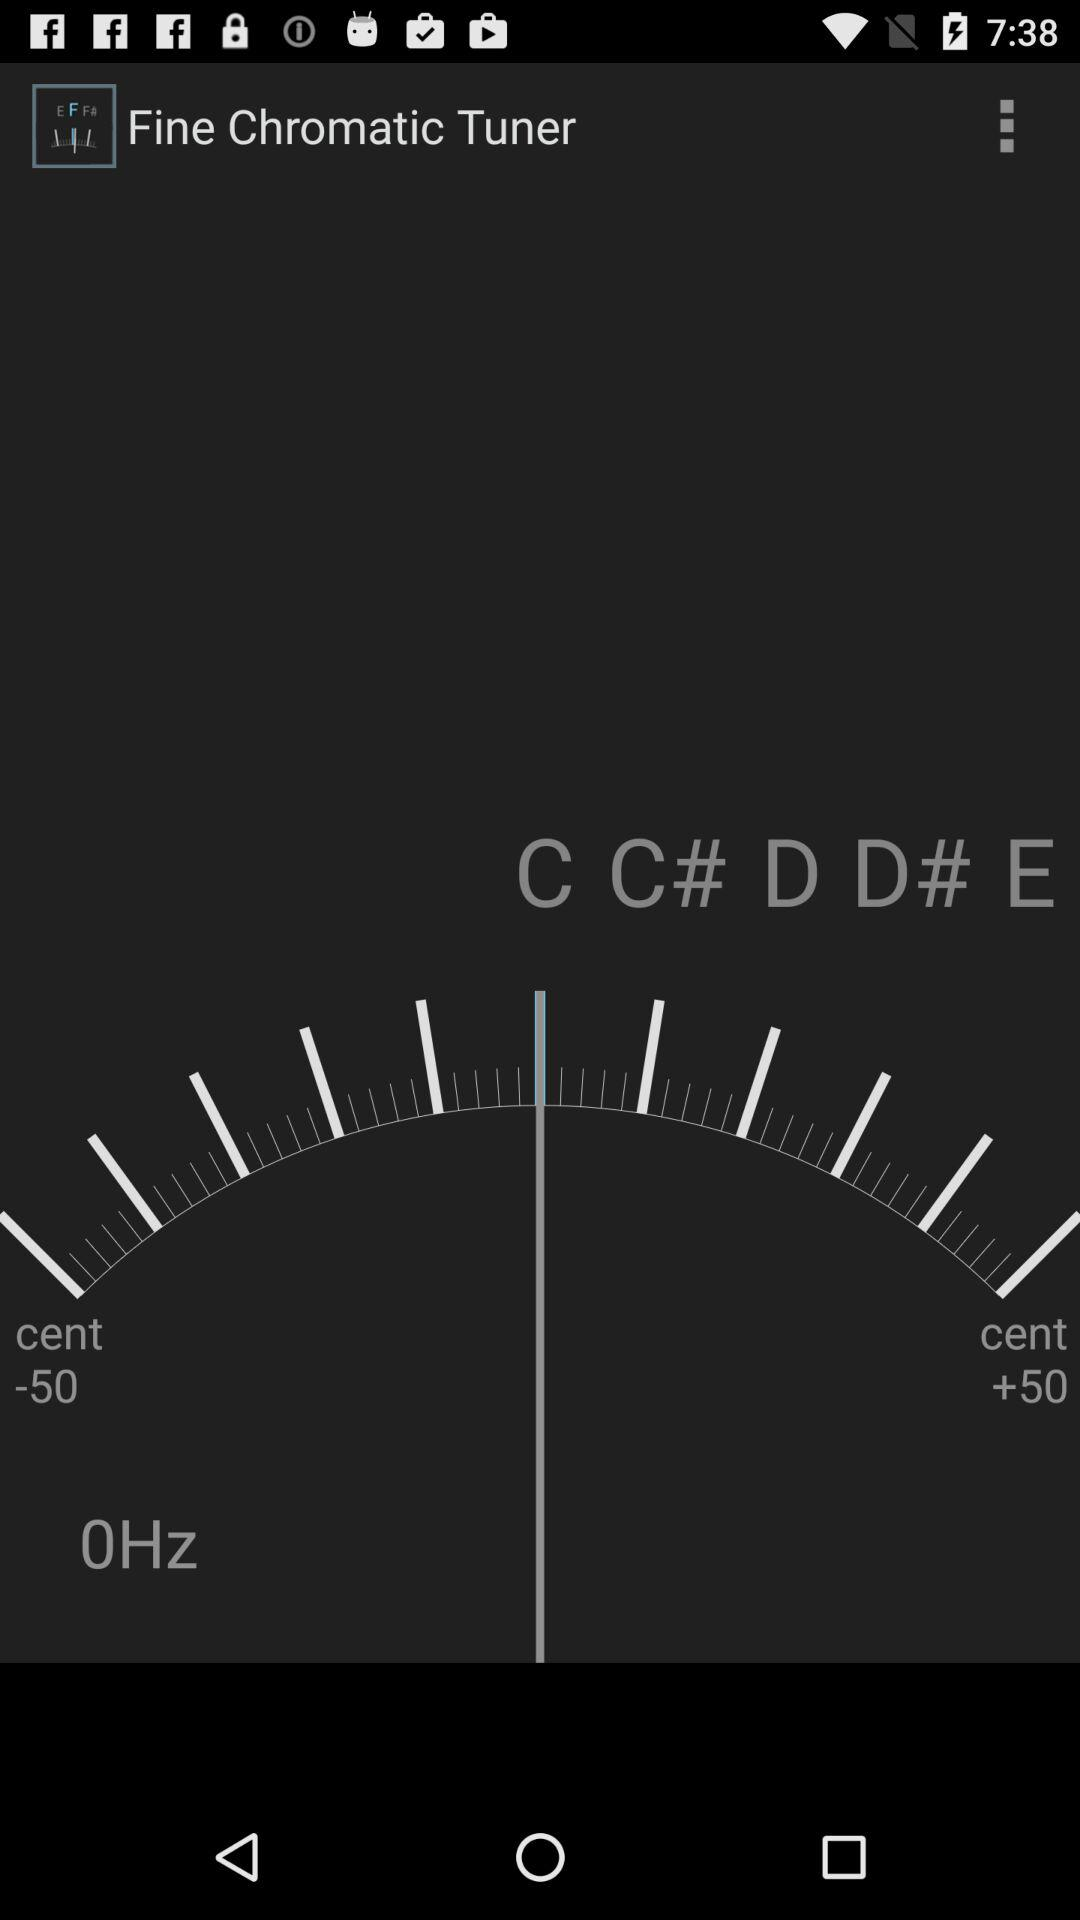What is the difference between the minimum and maximum cent values?
Answer the question using a single word or phrase. 100 